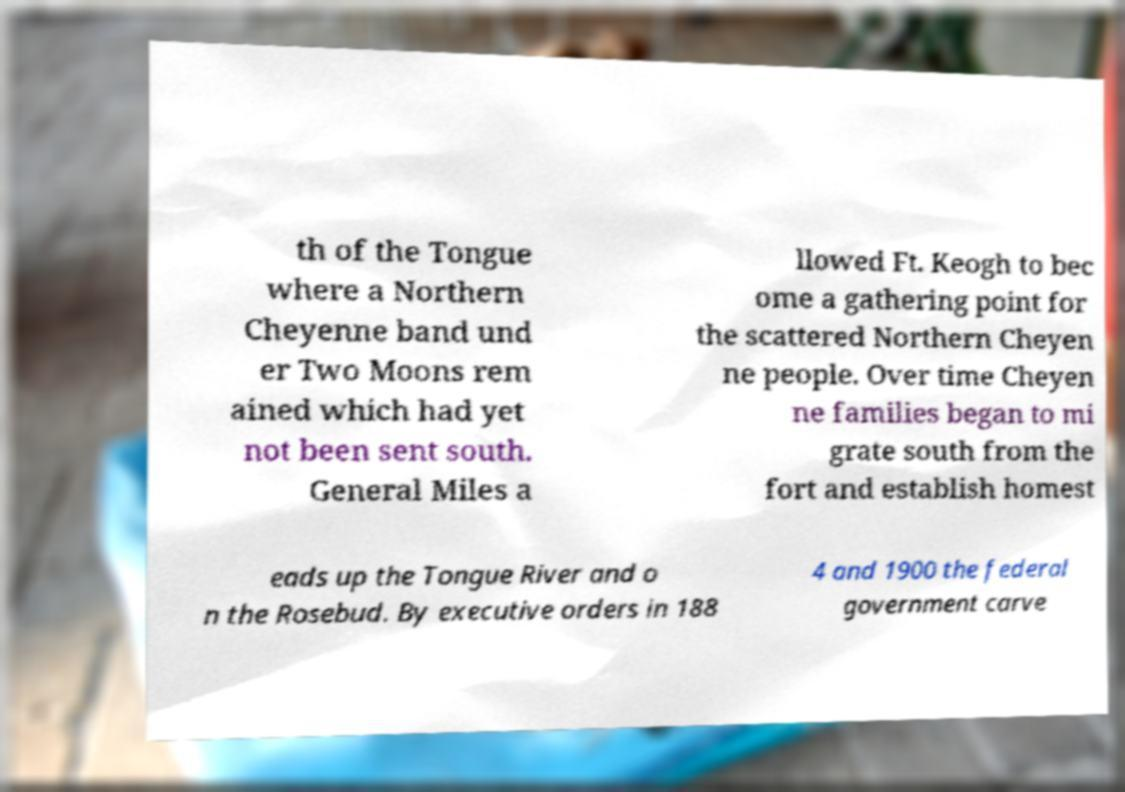Could you assist in decoding the text presented in this image and type it out clearly? th of the Tongue where a Northern Cheyenne band und er Two Moons rem ained which had yet not been sent south. General Miles a llowed Ft. Keogh to bec ome a gathering point for the scattered Northern Cheyen ne people. Over time Cheyen ne families began to mi grate south from the fort and establish homest eads up the Tongue River and o n the Rosebud. By executive orders in 188 4 and 1900 the federal government carve 